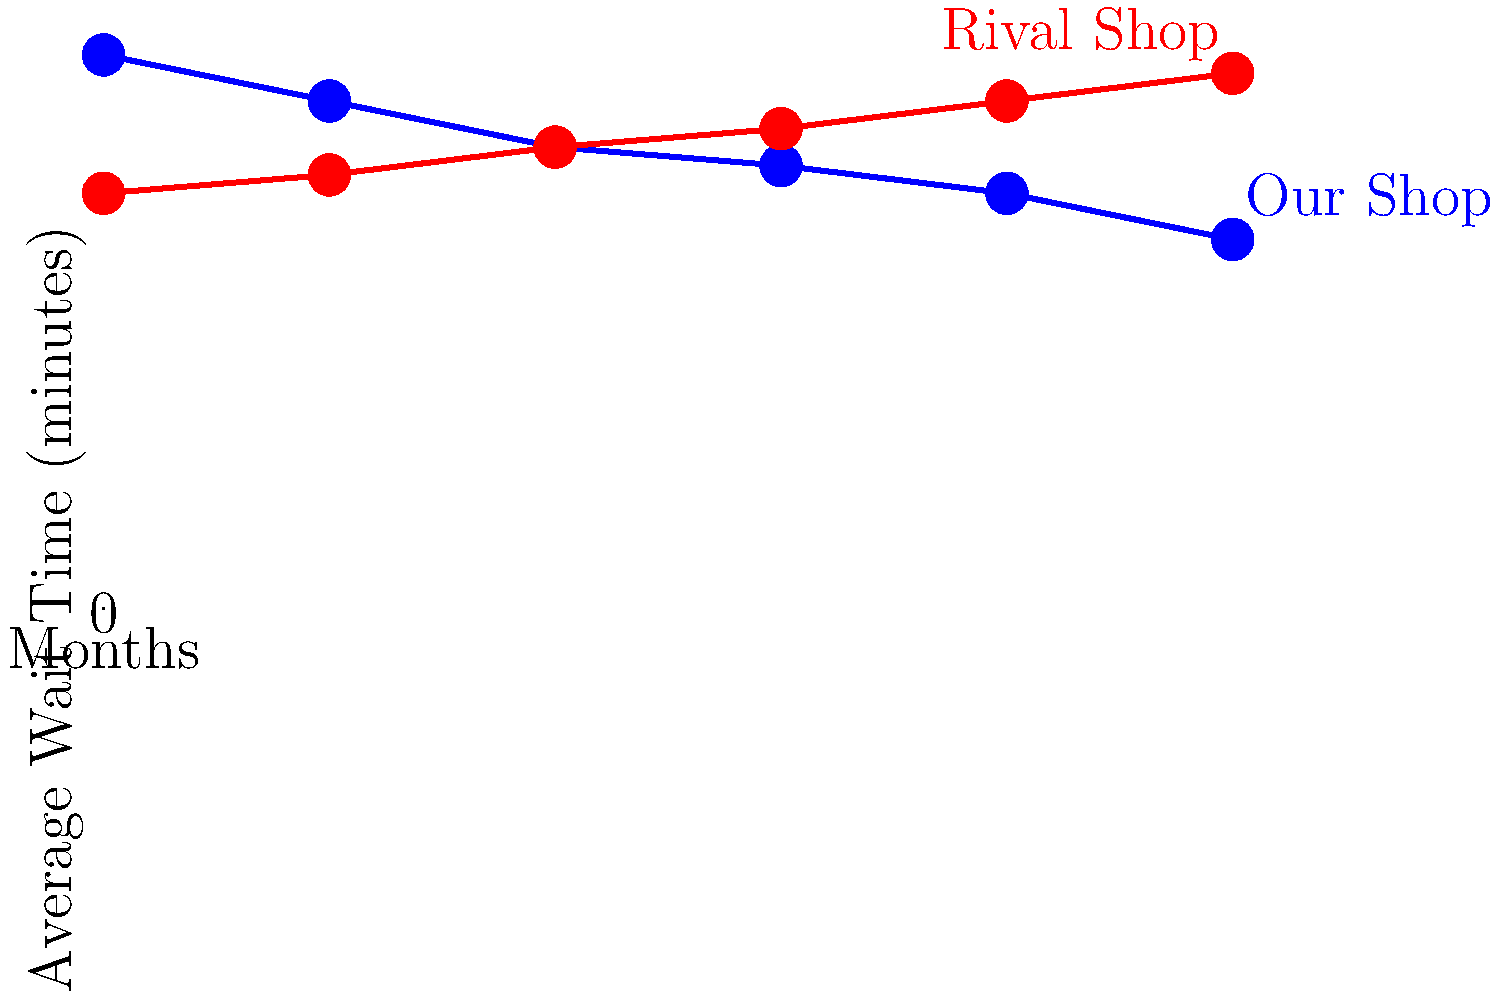Based on the line graph showing average wait times for two car repair shops over a 6-month period, at which month do the wait times for both shops become equal? To find the month when the wait times for both shops become equal, we need to follow these steps:

1. Observe the trend of both lines:
   - Our Shop (blue line): Decreasing wait time
   - Rival Shop (red line): Increasing wait time

2. Look for the intersection point of the two lines, which represents equal wait times.

3. Identify the month corresponding to this intersection point:
   - The lines cross between the 2nd and 3rd month on the x-axis.

4. Interpolate to find the exact point:
   - At month 2, Our Shop: 50 minutes, Rival Shop: 50 minutes
   - This is the point where the wait times are equal

5. Confirm that this is the only intersection point in the given time frame.

Therefore, the wait times for both shops become equal at month 2.
Answer: Month 2 